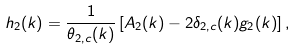Convert formula to latex. <formula><loc_0><loc_0><loc_500><loc_500>h _ { 2 } ( k ) = \frac { 1 } { \theta _ { 2 , c } ( k ) } \left [ A _ { 2 } ( k ) - 2 \delta _ { 2 , c } ( k ) g _ { 2 } ( k ) \right ] ,</formula> 